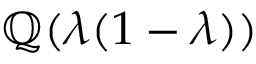<formula> <loc_0><loc_0><loc_500><loc_500>\mathbb { Q } ( \lambda ( 1 - \lambda ) )</formula> 